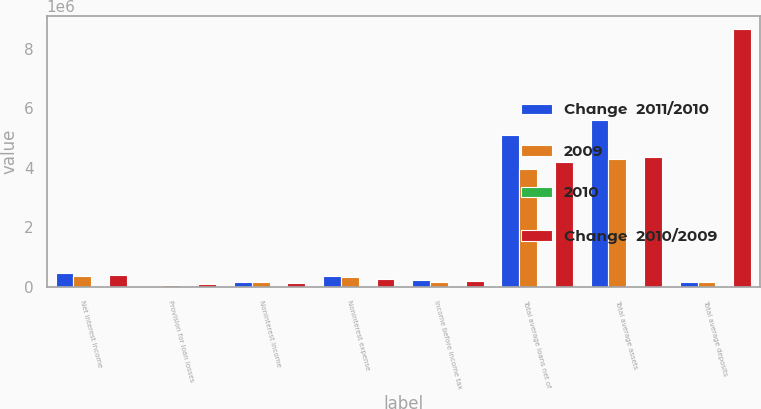<chart> <loc_0><loc_0><loc_500><loc_500><stacked_bar_chart><ecel><fcel>Net interest income<fcel>Provision for loan losses<fcel>Noninterest income<fcel>Noninterest expense<fcel>Income before income tax<fcel>Total average loans net of<fcel>Total average assets<fcel>Total average deposits<nl><fcel>Change  2011/2010<fcel>445466<fcel>13494<fcel>150116<fcel>358712<fcel>223376<fcel>5.09952e+06<fcel>5.60394e+06<fcel>166830<nl><fcel>2009<fcel>367927<fcel>42357<fcel>136531<fcel>307508<fcel>154593<fcel>3.94887e+06<fcel>4.28174e+06<fcel>166830<nl><fcel>2010<fcel>21.1<fcel>68.1<fcel>10<fcel>16.7<fcel>44.5<fcel>29.1<fcel>30.9<fcel>29<nl><fcel>Change  2010/2009<fcel>380668<fcel>79867<fcel>119834<fcel>241567<fcel>179068<fcel>4.18891e+06<fcel>4.3707e+06<fcel>8.67976e+06<nl></chart> 